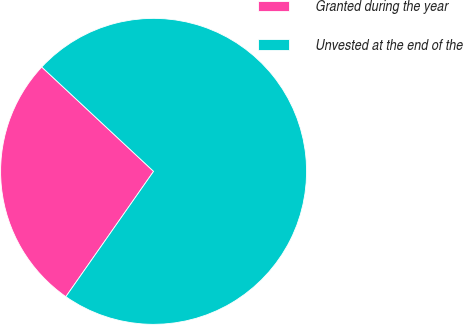Convert chart. <chart><loc_0><loc_0><loc_500><loc_500><pie_chart><fcel>Granted during the year<fcel>Unvested at the end of the<nl><fcel>27.23%<fcel>72.77%<nl></chart> 